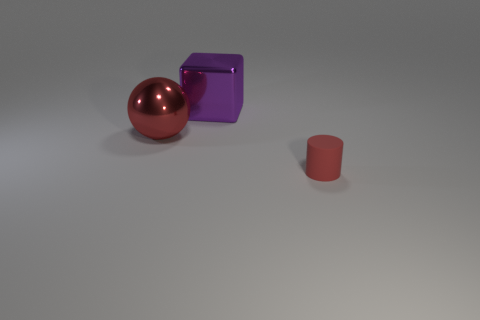Are there any other things that are made of the same material as the cylinder?
Provide a short and direct response. No. Is there a metal ball of the same size as the red matte cylinder?
Offer a very short reply. No. There is a metallic thing that is in front of the large cube; is its size the same as the red thing that is to the right of the large block?
Keep it short and to the point. No. Are there any gray rubber things that have the same shape as the small red rubber object?
Provide a short and direct response. No. Is the number of big red metallic balls behind the cube the same as the number of big green spheres?
Ensure brevity in your answer.  Yes. There is a metallic cube; is it the same size as the object on the left side of the big purple object?
Offer a very short reply. Yes. What number of small objects are the same material as the cylinder?
Your response must be concise. 0. Do the metallic block and the red matte object have the same size?
Your answer should be very brief. No. Are there any other things of the same color as the rubber cylinder?
Keep it short and to the point. Yes. What shape is the thing that is both on the right side of the large red metal sphere and to the left of the matte thing?
Your answer should be very brief. Cube. 